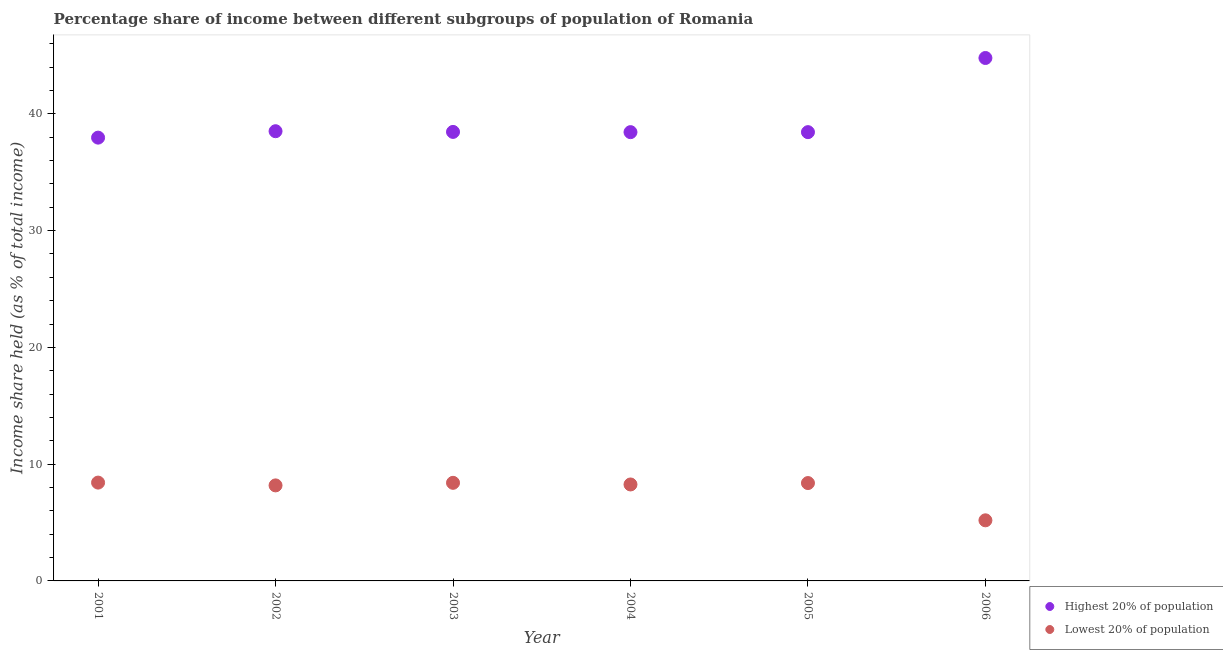How many different coloured dotlines are there?
Your answer should be compact. 2. Is the number of dotlines equal to the number of legend labels?
Your answer should be compact. Yes. What is the income share held by lowest 20% of the population in 2005?
Make the answer very short. 8.38. Across all years, what is the maximum income share held by lowest 20% of the population?
Provide a succinct answer. 8.42. Across all years, what is the minimum income share held by lowest 20% of the population?
Your answer should be very brief. 5.19. In which year was the income share held by highest 20% of the population maximum?
Give a very brief answer. 2006. What is the total income share held by highest 20% of the population in the graph?
Keep it short and to the point. 236.56. What is the difference between the income share held by lowest 20% of the population in 2001 and that in 2003?
Offer a terse response. 0.02. What is the difference between the income share held by lowest 20% of the population in 2001 and the income share held by highest 20% of the population in 2006?
Make the answer very short. -36.36. What is the average income share held by highest 20% of the population per year?
Provide a short and direct response. 39.43. In the year 2002, what is the difference between the income share held by lowest 20% of the population and income share held by highest 20% of the population?
Ensure brevity in your answer.  -30.33. What is the ratio of the income share held by lowest 20% of the population in 2001 to that in 2004?
Provide a short and direct response. 1.02. Is the income share held by lowest 20% of the population in 2001 less than that in 2006?
Ensure brevity in your answer.  No. Is the difference between the income share held by highest 20% of the population in 2004 and 2005 greater than the difference between the income share held by lowest 20% of the population in 2004 and 2005?
Your answer should be compact. Yes. What is the difference between the highest and the second highest income share held by highest 20% of the population?
Keep it short and to the point. 6.27. What is the difference between the highest and the lowest income share held by highest 20% of the population?
Give a very brief answer. 6.82. In how many years, is the income share held by lowest 20% of the population greater than the average income share held by lowest 20% of the population taken over all years?
Your answer should be compact. 5. Is the sum of the income share held by lowest 20% of the population in 2005 and 2006 greater than the maximum income share held by highest 20% of the population across all years?
Your answer should be very brief. No. Is the income share held by lowest 20% of the population strictly greater than the income share held by highest 20% of the population over the years?
Provide a short and direct response. No. Is the income share held by lowest 20% of the population strictly less than the income share held by highest 20% of the population over the years?
Your answer should be very brief. Yes. How many years are there in the graph?
Your response must be concise. 6. How many legend labels are there?
Your response must be concise. 2. What is the title of the graph?
Keep it short and to the point. Percentage share of income between different subgroups of population of Romania. Does "Formally registered" appear as one of the legend labels in the graph?
Ensure brevity in your answer.  No. What is the label or title of the X-axis?
Offer a terse response. Year. What is the label or title of the Y-axis?
Provide a short and direct response. Income share held (as % of total income). What is the Income share held (as % of total income) in Highest 20% of population in 2001?
Keep it short and to the point. 37.96. What is the Income share held (as % of total income) of Lowest 20% of population in 2001?
Make the answer very short. 8.42. What is the Income share held (as % of total income) of Highest 20% of population in 2002?
Your answer should be compact. 38.51. What is the Income share held (as % of total income) in Lowest 20% of population in 2002?
Your answer should be compact. 8.18. What is the Income share held (as % of total income) in Highest 20% of population in 2003?
Provide a short and direct response. 38.45. What is the Income share held (as % of total income) in Highest 20% of population in 2004?
Offer a very short reply. 38.43. What is the Income share held (as % of total income) of Lowest 20% of population in 2004?
Make the answer very short. 8.26. What is the Income share held (as % of total income) in Highest 20% of population in 2005?
Your answer should be compact. 38.43. What is the Income share held (as % of total income) in Lowest 20% of population in 2005?
Provide a short and direct response. 8.38. What is the Income share held (as % of total income) of Highest 20% of population in 2006?
Offer a very short reply. 44.78. What is the Income share held (as % of total income) of Lowest 20% of population in 2006?
Your answer should be compact. 5.19. Across all years, what is the maximum Income share held (as % of total income) in Highest 20% of population?
Provide a short and direct response. 44.78. Across all years, what is the maximum Income share held (as % of total income) of Lowest 20% of population?
Offer a terse response. 8.42. Across all years, what is the minimum Income share held (as % of total income) of Highest 20% of population?
Keep it short and to the point. 37.96. Across all years, what is the minimum Income share held (as % of total income) in Lowest 20% of population?
Your answer should be compact. 5.19. What is the total Income share held (as % of total income) of Highest 20% of population in the graph?
Provide a short and direct response. 236.56. What is the total Income share held (as % of total income) in Lowest 20% of population in the graph?
Your answer should be compact. 46.83. What is the difference between the Income share held (as % of total income) of Highest 20% of population in 2001 and that in 2002?
Your answer should be compact. -0.55. What is the difference between the Income share held (as % of total income) of Lowest 20% of population in 2001 and that in 2002?
Give a very brief answer. 0.24. What is the difference between the Income share held (as % of total income) in Highest 20% of population in 2001 and that in 2003?
Your answer should be compact. -0.49. What is the difference between the Income share held (as % of total income) in Lowest 20% of population in 2001 and that in 2003?
Provide a short and direct response. 0.02. What is the difference between the Income share held (as % of total income) of Highest 20% of population in 2001 and that in 2004?
Offer a terse response. -0.47. What is the difference between the Income share held (as % of total income) of Lowest 20% of population in 2001 and that in 2004?
Make the answer very short. 0.16. What is the difference between the Income share held (as % of total income) in Highest 20% of population in 2001 and that in 2005?
Offer a very short reply. -0.47. What is the difference between the Income share held (as % of total income) in Highest 20% of population in 2001 and that in 2006?
Provide a succinct answer. -6.82. What is the difference between the Income share held (as % of total income) in Lowest 20% of population in 2001 and that in 2006?
Offer a very short reply. 3.23. What is the difference between the Income share held (as % of total income) of Lowest 20% of population in 2002 and that in 2003?
Make the answer very short. -0.22. What is the difference between the Income share held (as % of total income) of Highest 20% of population in 2002 and that in 2004?
Give a very brief answer. 0.08. What is the difference between the Income share held (as % of total income) of Lowest 20% of population in 2002 and that in 2004?
Give a very brief answer. -0.08. What is the difference between the Income share held (as % of total income) of Lowest 20% of population in 2002 and that in 2005?
Your answer should be compact. -0.2. What is the difference between the Income share held (as % of total income) in Highest 20% of population in 2002 and that in 2006?
Your response must be concise. -6.27. What is the difference between the Income share held (as % of total income) in Lowest 20% of population in 2002 and that in 2006?
Provide a succinct answer. 2.99. What is the difference between the Income share held (as % of total income) of Highest 20% of population in 2003 and that in 2004?
Your answer should be very brief. 0.02. What is the difference between the Income share held (as % of total income) of Lowest 20% of population in 2003 and that in 2004?
Ensure brevity in your answer.  0.14. What is the difference between the Income share held (as % of total income) of Highest 20% of population in 2003 and that in 2006?
Provide a succinct answer. -6.33. What is the difference between the Income share held (as % of total income) in Lowest 20% of population in 2003 and that in 2006?
Keep it short and to the point. 3.21. What is the difference between the Income share held (as % of total income) of Lowest 20% of population in 2004 and that in 2005?
Make the answer very short. -0.12. What is the difference between the Income share held (as % of total income) of Highest 20% of population in 2004 and that in 2006?
Your response must be concise. -6.35. What is the difference between the Income share held (as % of total income) of Lowest 20% of population in 2004 and that in 2006?
Provide a short and direct response. 3.07. What is the difference between the Income share held (as % of total income) of Highest 20% of population in 2005 and that in 2006?
Provide a succinct answer. -6.35. What is the difference between the Income share held (as % of total income) in Lowest 20% of population in 2005 and that in 2006?
Offer a terse response. 3.19. What is the difference between the Income share held (as % of total income) of Highest 20% of population in 2001 and the Income share held (as % of total income) of Lowest 20% of population in 2002?
Provide a succinct answer. 29.78. What is the difference between the Income share held (as % of total income) in Highest 20% of population in 2001 and the Income share held (as % of total income) in Lowest 20% of population in 2003?
Your response must be concise. 29.56. What is the difference between the Income share held (as % of total income) in Highest 20% of population in 2001 and the Income share held (as % of total income) in Lowest 20% of population in 2004?
Keep it short and to the point. 29.7. What is the difference between the Income share held (as % of total income) of Highest 20% of population in 2001 and the Income share held (as % of total income) of Lowest 20% of population in 2005?
Your answer should be compact. 29.58. What is the difference between the Income share held (as % of total income) of Highest 20% of population in 2001 and the Income share held (as % of total income) of Lowest 20% of population in 2006?
Keep it short and to the point. 32.77. What is the difference between the Income share held (as % of total income) in Highest 20% of population in 2002 and the Income share held (as % of total income) in Lowest 20% of population in 2003?
Provide a short and direct response. 30.11. What is the difference between the Income share held (as % of total income) of Highest 20% of population in 2002 and the Income share held (as % of total income) of Lowest 20% of population in 2004?
Give a very brief answer. 30.25. What is the difference between the Income share held (as % of total income) of Highest 20% of population in 2002 and the Income share held (as % of total income) of Lowest 20% of population in 2005?
Offer a terse response. 30.13. What is the difference between the Income share held (as % of total income) in Highest 20% of population in 2002 and the Income share held (as % of total income) in Lowest 20% of population in 2006?
Provide a succinct answer. 33.32. What is the difference between the Income share held (as % of total income) in Highest 20% of population in 2003 and the Income share held (as % of total income) in Lowest 20% of population in 2004?
Keep it short and to the point. 30.19. What is the difference between the Income share held (as % of total income) of Highest 20% of population in 2003 and the Income share held (as % of total income) of Lowest 20% of population in 2005?
Give a very brief answer. 30.07. What is the difference between the Income share held (as % of total income) of Highest 20% of population in 2003 and the Income share held (as % of total income) of Lowest 20% of population in 2006?
Give a very brief answer. 33.26. What is the difference between the Income share held (as % of total income) in Highest 20% of population in 2004 and the Income share held (as % of total income) in Lowest 20% of population in 2005?
Your response must be concise. 30.05. What is the difference between the Income share held (as % of total income) of Highest 20% of population in 2004 and the Income share held (as % of total income) of Lowest 20% of population in 2006?
Offer a very short reply. 33.24. What is the difference between the Income share held (as % of total income) of Highest 20% of population in 2005 and the Income share held (as % of total income) of Lowest 20% of population in 2006?
Give a very brief answer. 33.24. What is the average Income share held (as % of total income) of Highest 20% of population per year?
Ensure brevity in your answer.  39.43. What is the average Income share held (as % of total income) of Lowest 20% of population per year?
Offer a very short reply. 7.8. In the year 2001, what is the difference between the Income share held (as % of total income) of Highest 20% of population and Income share held (as % of total income) of Lowest 20% of population?
Provide a succinct answer. 29.54. In the year 2002, what is the difference between the Income share held (as % of total income) of Highest 20% of population and Income share held (as % of total income) of Lowest 20% of population?
Offer a very short reply. 30.33. In the year 2003, what is the difference between the Income share held (as % of total income) of Highest 20% of population and Income share held (as % of total income) of Lowest 20% of population?
Your answer should be very brief. 30.05. In the year 2004, what is the difference between the Income share held (as % of total income) in Highest 20% of population and Income share held (as % of total income) in Lowest 20% of population?
Keep it short and to the point. 30.17. In the year 2005, what is the difference between the Income share held (as % of total income) of Highest 20% of population and Income share held (as % of total income) of Lowest 20% of population?
Your response must be concise. 30.05. In the year 2006, what is the difference between the Income share held (as % of total income) in Highest 20% of population and Income share held (as % of total income) in Lowest 20% of population?
Your answer should be compact. 39.59. What is the ratio of the Income share held (as % of total income) in Highest 20% of population in 2001 to that in 2002?
Provide a succinct answer. 0.99. What is the ratio of the Income share held (as % of total income) of Lowest 20% of population in 2001 to that in 2002?
Make the answer very short. 1.03. What is the ratio of the Income share held (as % of total income) in Highest 20% of population in 2001 to that in 2003?
Ensure brevity in your answer.  0.99. What is the ratio of the Income share held (as % of total income) of Lowest 20% of population in 2001 to that in 2003?
Your answer should be very brief. 1. What is the ratio of the Income share held (as % of total income) in Highest 20% of population in 2001 to that in 2004?
Your answer should be very brief. 0.99. What is the ratio of the Income share held (as % of total income) in Lowest 20% of population in 2001 to that in 2004?
Provide a succinct answer. 1.02. What is the ratio of the Income share held (as % of total income) of Highest 20% of population in 2001 to that in 2005?
Keep it short and to the point. 0.99. What is the ratio of the Income share held (as % of total income) of Highest 20% of population in 2001 to that in 2006?
Give a very brief answer. 0.85. What is the ratio of the Income share held (as % of total income) in Lowest 20% of population in 2001 to that in 2006?
Your response must be concise. 1.62. What is the ratio of the Income share held (as % of total income) in Lowest 20% of population in 2002 to that in 2003?
Give a very brief answer. 0.97. What is the ratio of the Income share held (as % of total income) in Highest 20% of population in 2002 to that in 2004?
Give a very brief answer. 1. What is the ratio of the Income share held (as % of total income) in Lowest 20% of population in 2002 to that in 2004?
Keep it short and to the point. 0.99. What is the ratio of the Income share held (as % of total income) in Lowest 20% of population in 2002 to that in 2005?
Offer a terse response. 0.98. What is the ratio of the Income share held (as % of total income) of Highest 20% of population in 2002 to that in 2006?
Your answer should be very brief. 0.86. What is the ratio of the Income share held (as % of total income) in Lowest 20% of population in 2002 to that in 2006?
Offer a very short reply. 1.58. What is the ratio of the Income share held (as % of total income) in Lowest 20% of population in 2003 to that in 2004?
Make the answer very short. 1.02. What is the ratio of the Income share held (as % of total income) in Highest 20% of population in 2003 to that in 2005?
Provide a short and direct response. 1. What is the ratio of the Income share held (as % of total income) in Lowest 20% of population in 2003 to that in 2005?
Your answer should be compact. 1. What is the ratio of the Income share held (as % of total income) of Highest 20% of population in 2003 to that in 2006?
Offer a very short reply. 0.86. What is the ratio of the Income share held (as % of total income) in Lowest 20% of population in 2003 to that in 2006?
Provide a succinct answer. 1.62. What is the ratio of the Income share held (as % of total income) in Lowest 20% of population in 2004 to that in 2005?
Your answer should be compact. 0.99. What is the ratio of the Income share held (as % of total income) of Highest 20% of population in 2004 to that in 2006?
Provide a succinct answer. 0.86. What is the ratio of the Income share held (as % of total income) of Lowest 20% of population in 2004 to that in 2006?
Offer a terse response. 1.59. What is the ratio of the Income share held (as % of total income) of Highest 20% of population in 2005 to that in 2006?
Keep it short and to the point. 0.86. What is the ratio of the Income share held (as % of total income) of Lowest 20% of population in 2005 to that in 2006?
Offer a very short reply. 1.61. What is the difference between the highest and the second highest Income share held (as % of total income) of Highest 20% of population?
Your answer should be compact. 6.27. What is the difference between the highest and the lowest Income share held (as % of total income) of Highest 20% of population?
Make the answer very short. 6.82. What is the difference between the highest and the lowest Income share held (as % of total income) of Lowest 20% of population?
Make the answer very short. 3.23. 